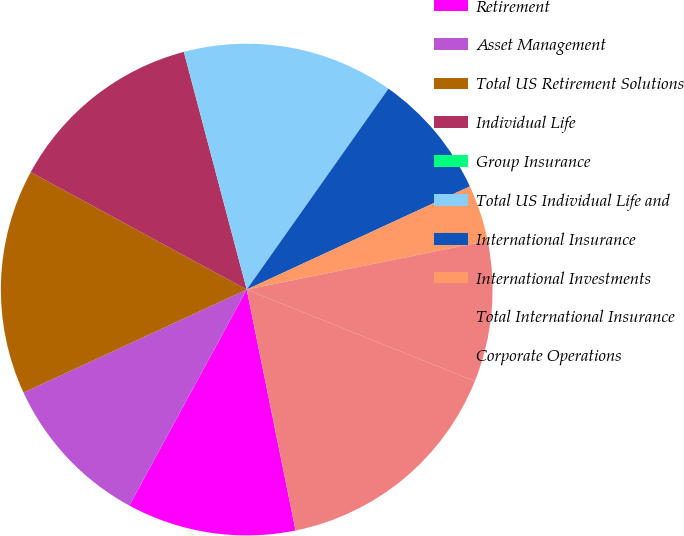Convert chart to OTSL. <chart><loc_0><loc_0><loc_500><loc_500><pie_chart><fcel>Retirement<fcel>Asset Management<fcel>Total US Retirement Solutions<fcel>Individual Life<fcel>Group Insurance<fcel>Total US Individual Life and<fcel>International Insurance<fcel>International Investments<fcel>Total International Insurance<fcel>Corporate Operations<nl><fcel>11.11%<fcel>10.19%<fcel>14.81%<fcel>12.96%<fcel>0.01%<fcel>13.89%<fcel>8.33%<fcel>3.71%<fcel>9.26%<fcel>15.74%<nl></chart> 